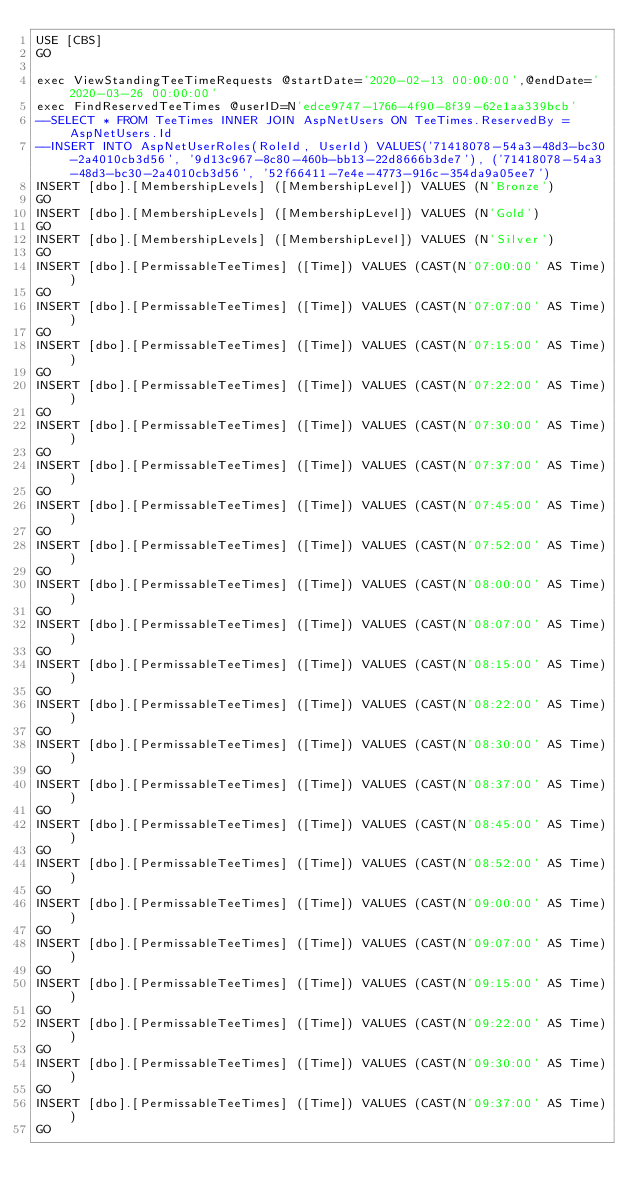Convert code to text. <code><loc_0><loc_0><loc_500><loc_500><_SQL_>USE [CBS]
GO

exec ViewStandingTeeTimeRequests @startDate='2020-02-13 00:00:00',@endDate='2020-03-26 00:00:00'
exec FindReservedTeeTimes @userID=N'edce9747-1766-4f90-8f39-62e1aa339bcb'
--SELECT * FROM TeeTimes INNER JOIN AspNetUsers ON TeeTimes.ReservedBy = AspNetUsers.Id
--INSERT INTO AspNetUserRoles(RoleId, UserId) VALUES('71418078-54a3-48d3-bc30-2a4010cb3d56', '9d13c967-8c80-460b-bb13-22d8666b3de7'), ('71418078-54a3-48d3-bc30-2a4010cb3d56', '52f66411-7e4e-4773-916c-354da9a05ee7')
INSERT [dbo].[MembershipLevels] ([MembershipLevel]) VALUES (N'Bronze')
GO
INSERT [dbo].[MembershipLevels] ([MembershipLevel]) VALUES (N'Gold')
GO
INSERT [dbo].[MembershipLevels] ([MembershipLevel]) VALUES (N'Silver')
GO
INSERT [dbo].[PermissableTeeTimes] ([Time]) VALUES (CAST(N'07:00:00' AS Time))
GO
INSERT [dbo].[PermissableTeeTimes] ([Time]) VALUES (CAST(N'07:07:00' AS Time))
GO
INSERT [dbo].[PermissableTeeTimes] ([Time]) VALUES (CAST(N'07:15:00' AS Time))
GO
INSERT [dbo].[PermissableTeeTimes] ([Time]) VALUES (CAST(N'07:22:00' AS Time))
GO
INSERT [dbo].[PermissableTeeTimes] ([Time]) VALUES (CAST(N'07:30:00' AS Time))
GO
INSERT [dbo].[PermissableTeeTimes] ([Time]) VALUES (CAST(N'07:37:00' AS Time))
GO
INSERT [dbo].[PermissableTeeTimes] ([Time]) VALUES (CAST(N'07:45:00' AS Time))
GO
INSERT [dbo].[PermissableTeeTimes] ([Time]) VALUES (CAST(N'07:52:00' AS Time))
GO
INSERT [dbo].[PermissableTeeTimes] ([Time]) VALUES (CAST(N'08:00:00' AS Time))
GO
INSERT [dbo].[PermissableTeeTimes] ([Time]) VALUES (CAST(N'08:07:00' AS Time))
GO
INSERT [dbo].[PermissableTeeTimes] ([Time]) VALUES (CAST(N'08:15:00' AS Time))
GO
INSERT [dbo].[PermissableTeeTimes] ([Time]) VALUES (CAST(N'08:22:00' AS Time))
GO
INSERT [dbo].[PermissableTeeTimes] ([Time]) VALUES (CAST(N'08:30:00' AS Time))
GO
INSERT [dbo].[PermissableTeeTimes] ([Time]) VALUES (CAST(N'08:37:00' AS Time))
GO
INSERT [dbo].[PermissableTeeTimes] ([Time]) VALUES (CAST(N'08:45:00' AS Time))
GO
INSERT [dbo].[PermissableTeeTimes] ([Time]) VALUES (CAST(N'08:52:00' AS Time))
GO
INSERT [dbo].[PermissableTeeTimes] ([Time]) VALUES (CAST(N'09:00:00' AS Time))
GO
INSERT [dbo].[PermissableTeeTimes] ([Time]) VALUES (CAST(N'09:07:00' AS Time))
GO
INSERT [dbo].[PermissableTeeTimes] ([Time]) VALUES (CAST(N'09:15:00' AS Time))
GO
INSERT [dbo].[PermissableTeeTimes] ([Time]) VALUES (CAST(N'09:22:00' AS Time))
GO
INSERT [dbo].[PermissableTeeTimes] ([Time]) VALUES (CAST(N'09:30:00' AS Time))
GO
INSERT [dbo].[PermissableTeeTimes] ([Time]) VALUES (CAST(N'09:37:00' AS Time))
GO</code> 